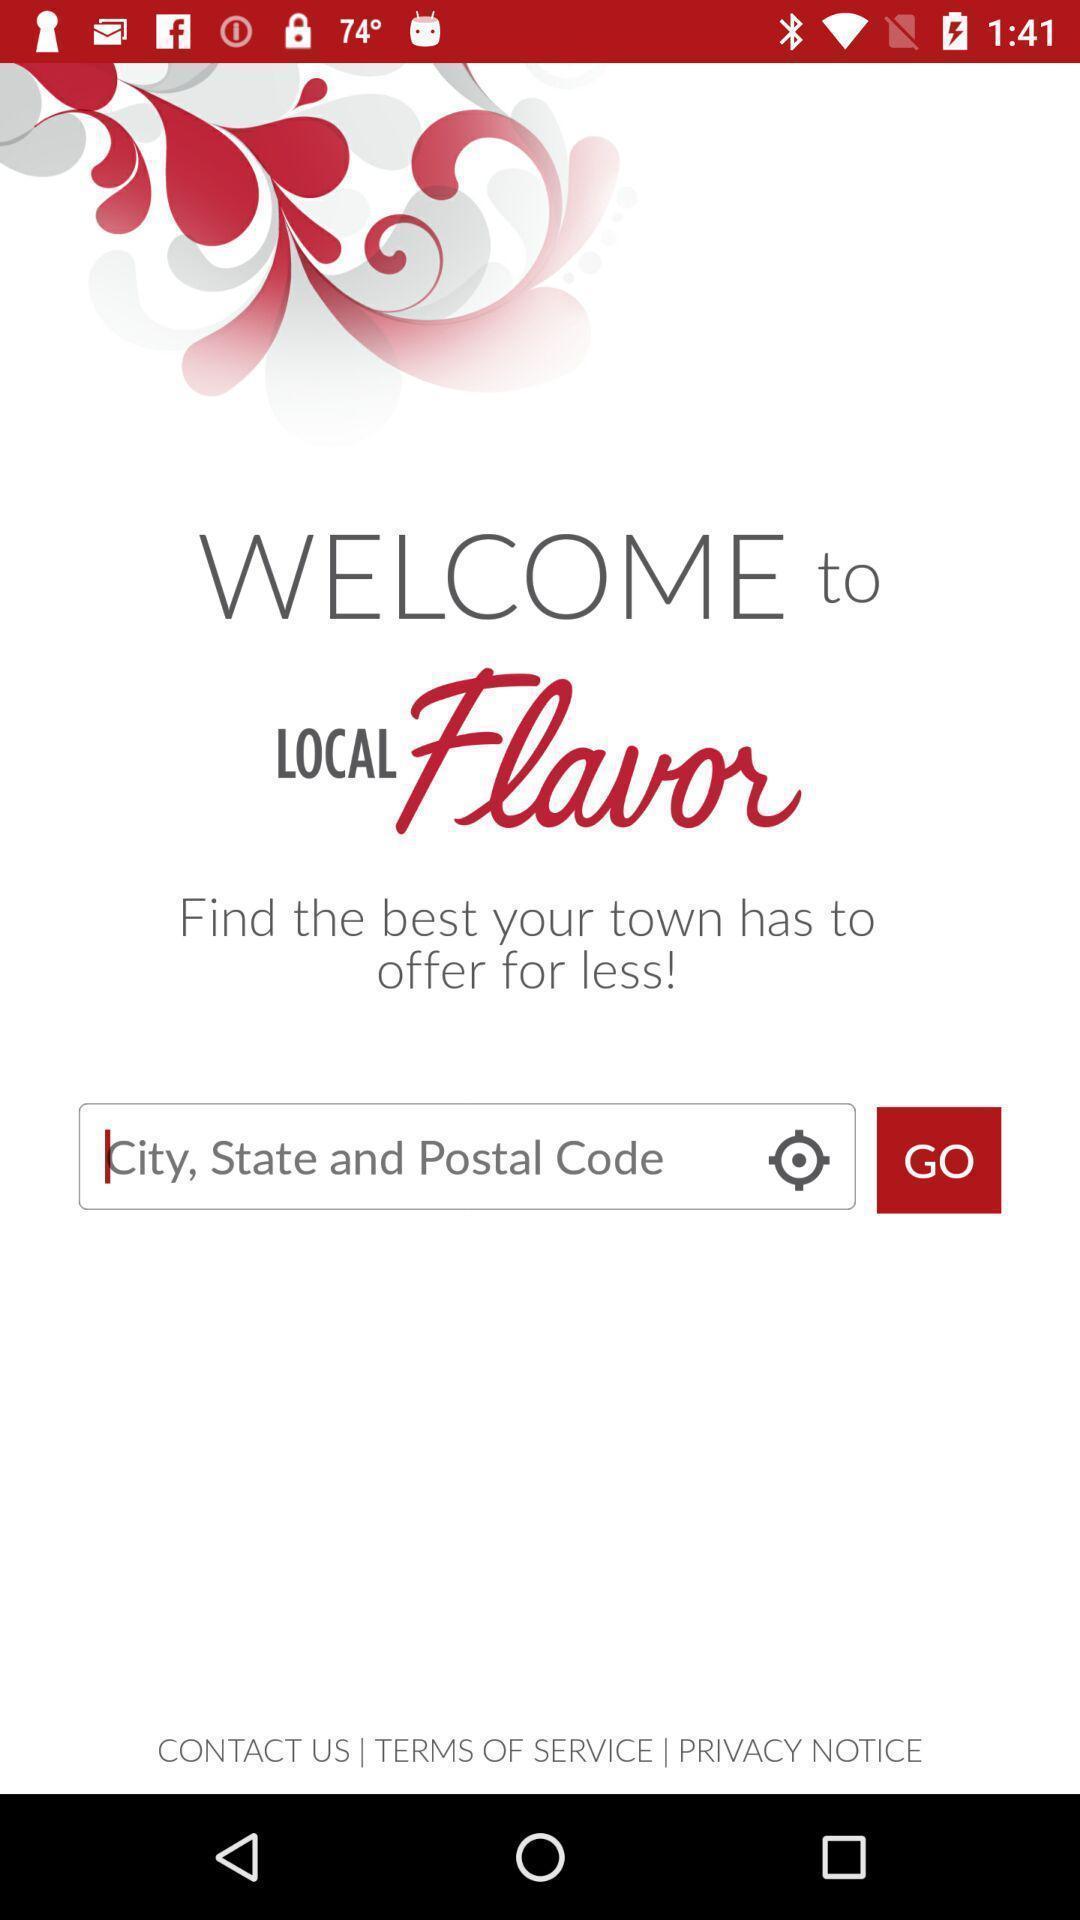Give me a summary of this screen capture. Welcome screen showing search bar. 